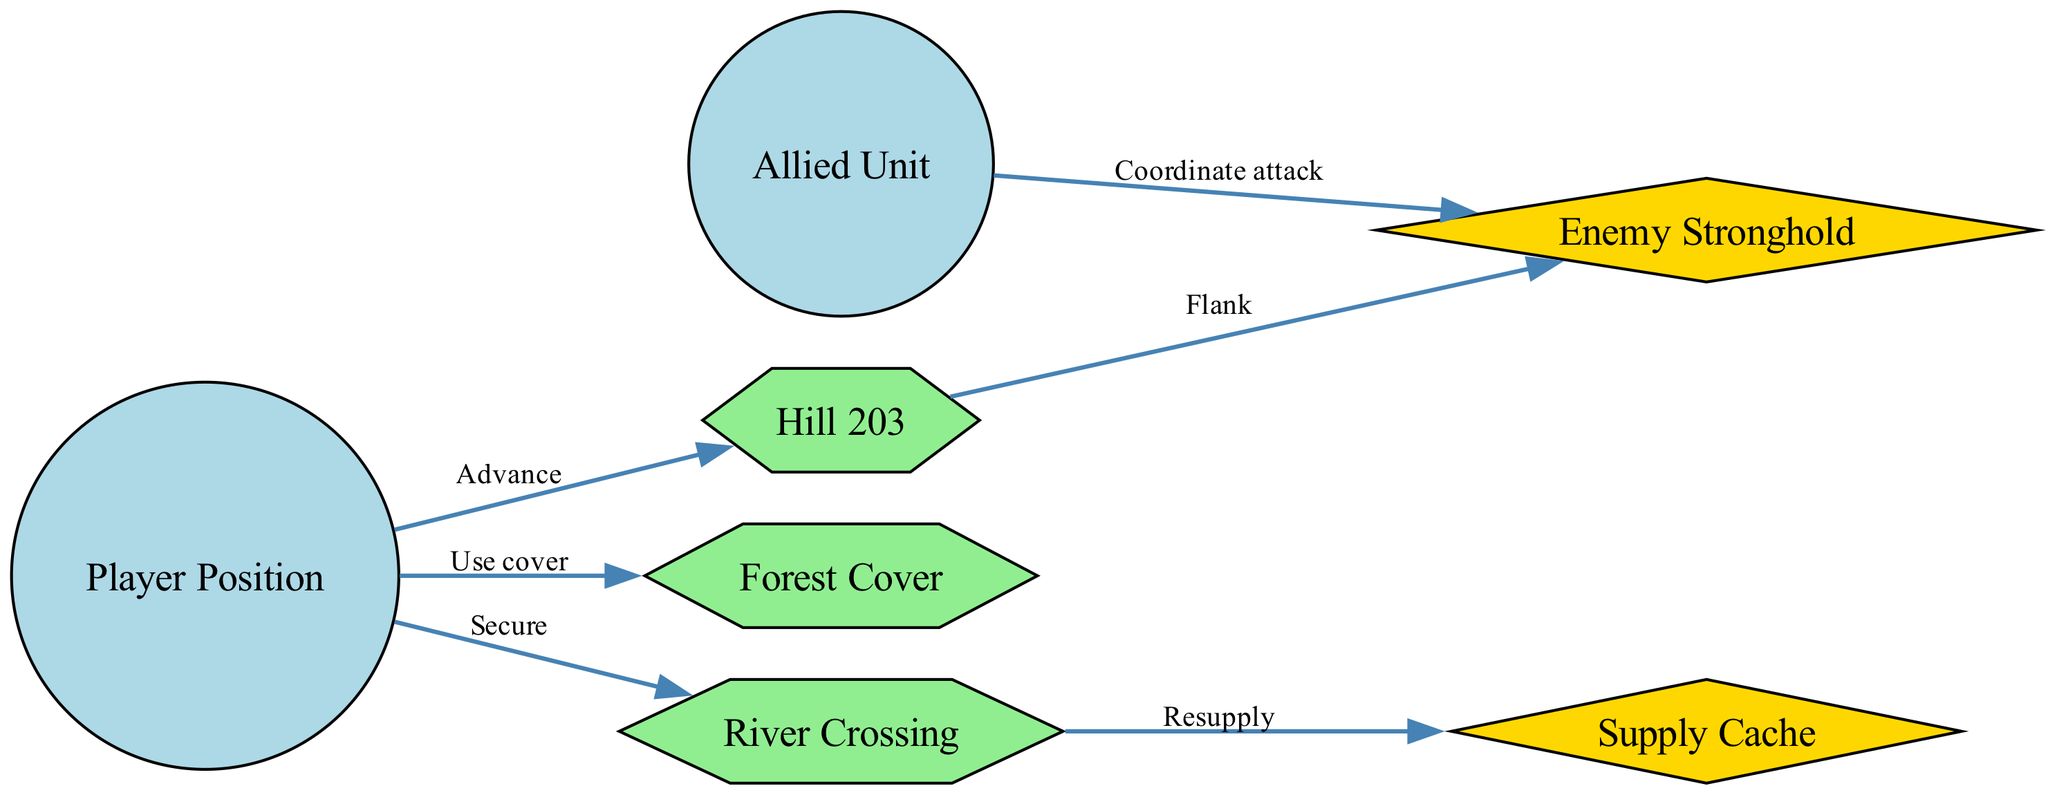What is the player’s position labeled as? The diagram shows a node labeled "Player Position," which represents the location of the player's unit.
Answer: Player Position How many terrain features are shown on the map? The diagram includes three nodes that are categorized as terrain features: Hill 203, River Crossing, and Forest Cover. Therefore, we count them to determine the total.
Answer: 3 What is the objective located at the River Crossing? An examination of the connections in the diagram reveals that the edge from River Crossing to the Supply Cache indicates a resupply operation, making the Supply Cache the objective associated with the River Crossing.
Answer: Supply Cache Which unit is tasked with coordinating attack on the Enemy Stronghold? The diagram displays an edge labeled "Coordinate attack" from the node representing the Allied Unit to the Enemy Stronghold, identifying the unit responsible for this task.
Answer: Allied Unit What two actions can the player take towards Hill 203? The player has two distinct edges directed towards Hill 203, labeled "Advance" from Player Position and "Flank" from Hill 203 to the Enemy Stronghold. This indicates the player can first advance to reach the hill and then attempt to flank the enemy.
Answer: Advance, Flank How does the player secure the River Crossing? The diagram indicates there is an edge labeled "Secure" that directly connects the Player Position to the River Crossing, showing the action the player needs to take in order to secure this position.
Answer: Secure What feature provides cover for the player? From examining the diagram, we see that the edge labeled "Use cover" connects the Player Position to the Forest Cover, indicating that the Forest Cover is intended to provide defensive support for the player.
Answer: Forest Cover What is the strategic objective closest to the player? Analyzing the diagram’s layout, the River Crossing is indicated as a connection point for the player, and along with edges, it is established as an operational objective, making it the closest strategic point for the player.
Answer: River Crossing In total, how many units are represented in this tactical map? By reviewing the nodes in the diagram, we see there are two units pictured: Player Position and Allied Unit. We can thus count them to find the total.
Answer: 2 